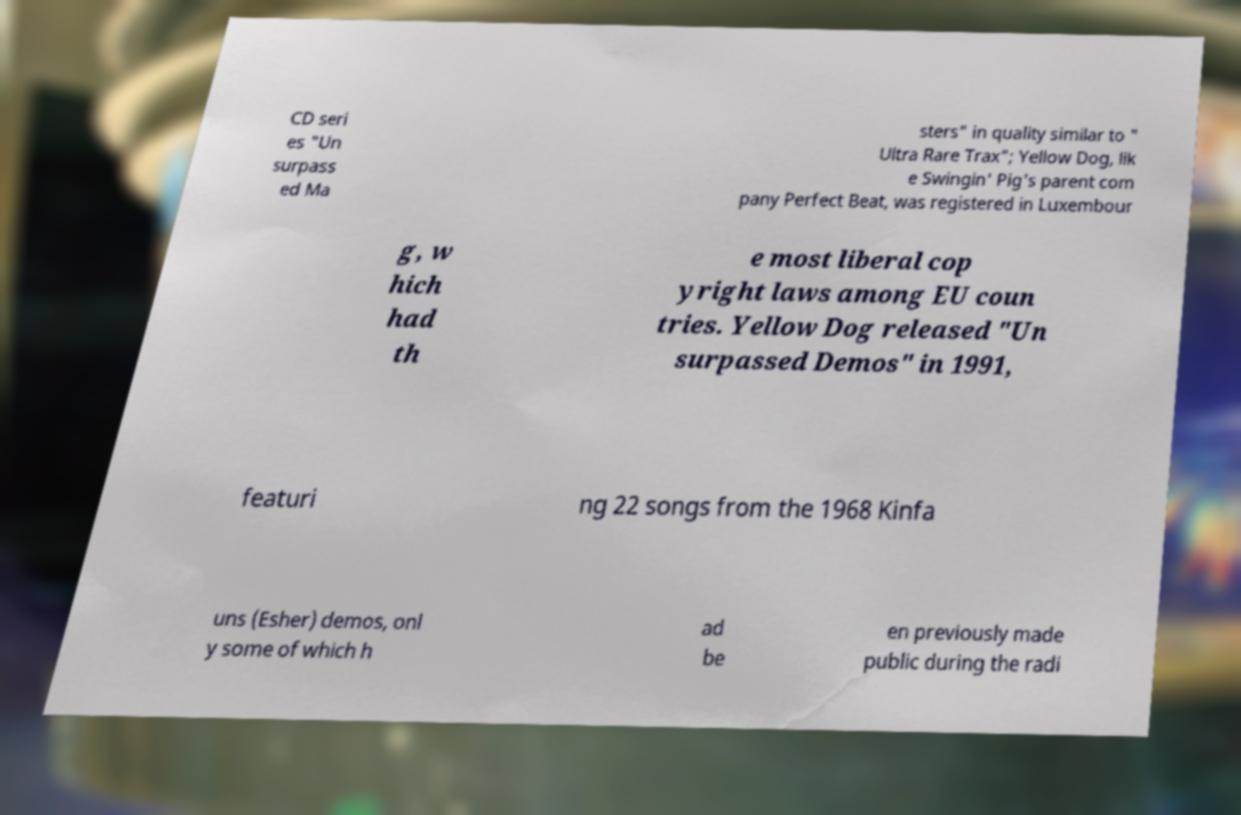Please read and relay the text visible in this image. What does it say? CD seri es "Un surpass ed Ma sters" in quality similar to " Ultra Rare Trax"; Yellow Dog, lik e Swingin' Pig's parent com pany Perfect Beat, was registered in Luxembour g, w hich had th e most liberal cop yright laws among EU coun tries. Yellow Dog released "Un surpassed Demos" in 1991, featuri ng 22 songs from the 1968 Kinfa uns (Esher) demos, onl y some of which h ad be en previously made public during the radi 